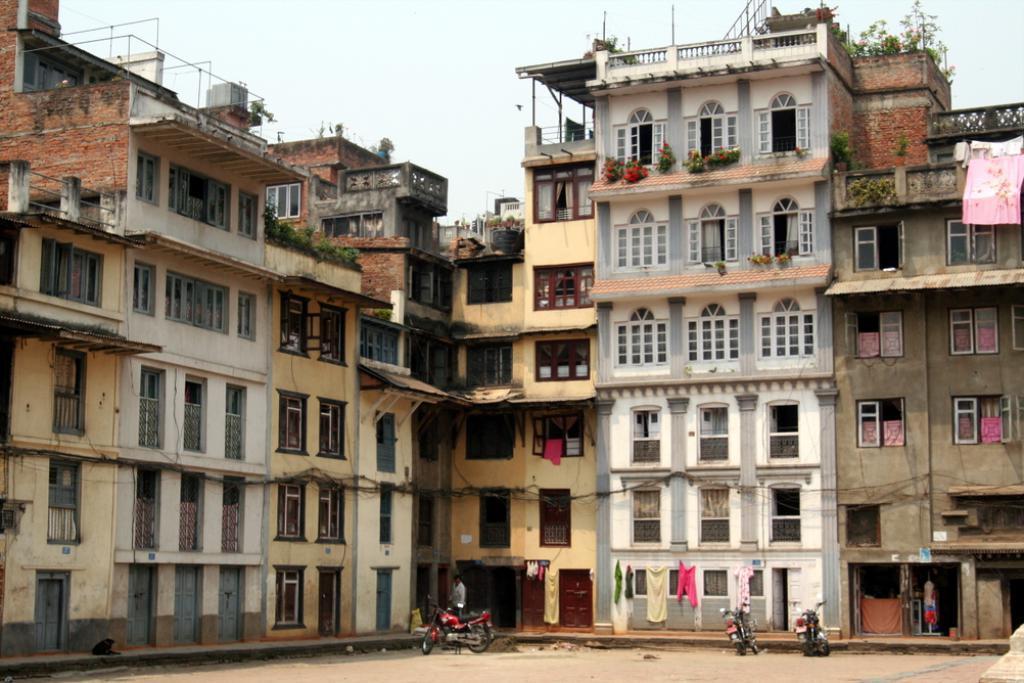Can you describe this image briefly? In this image we can see the buildings, there are some windows, vehicles, plants and flower, also we can see some clothes and in the background, we can see the sky. 